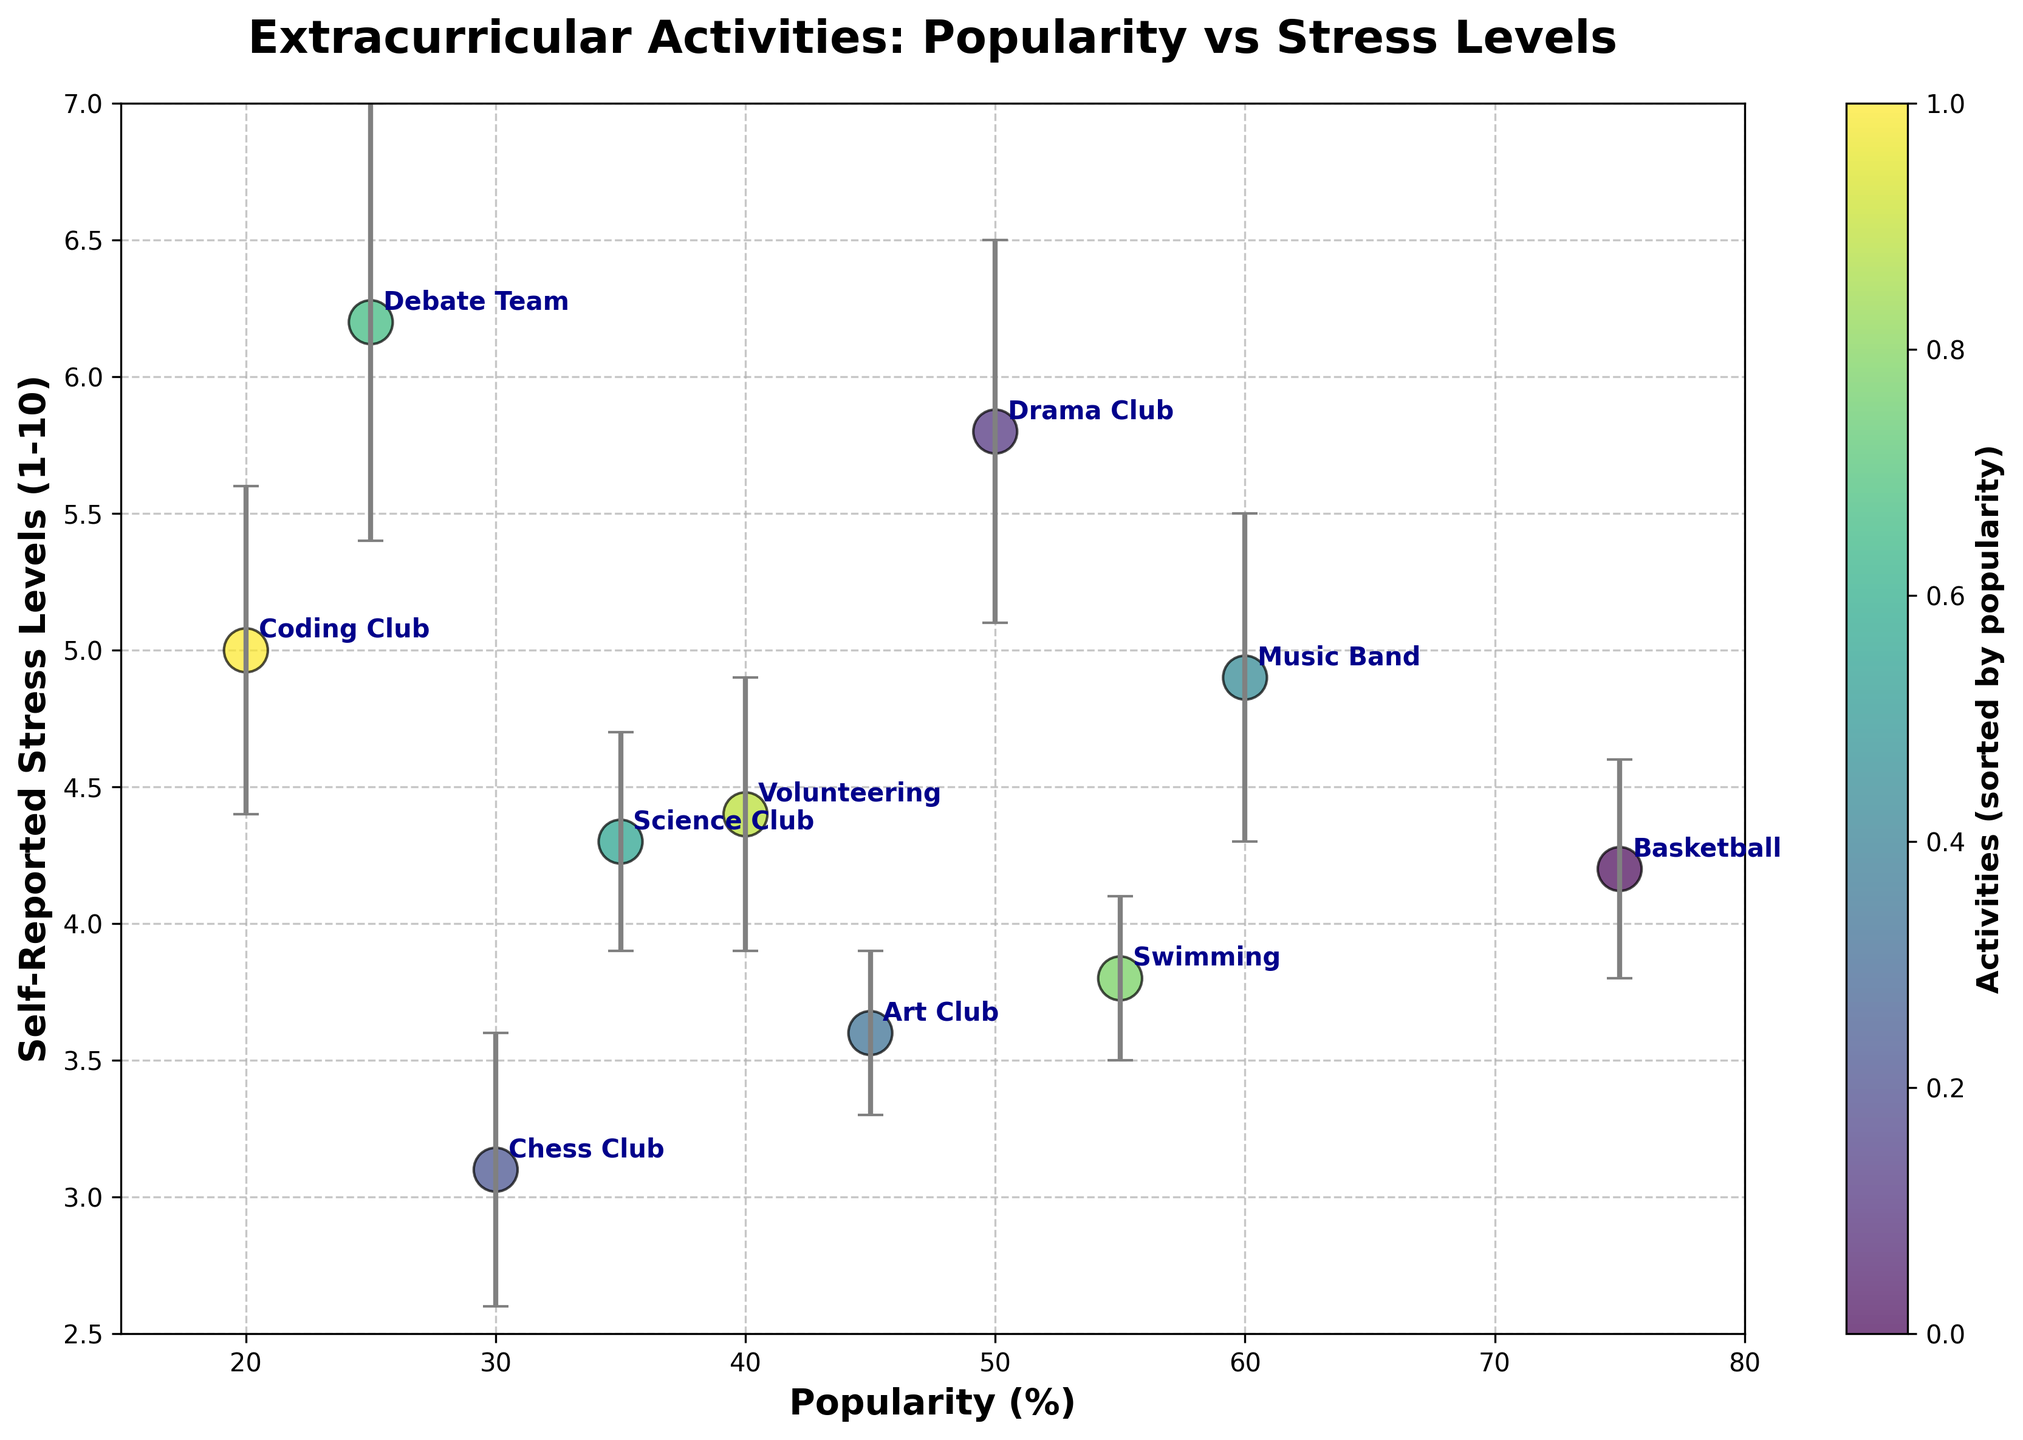Which activity has the highest popularity? To find the activity with the highest popularity, look at the x-axis and identify the point with the highest value. The activity plotted at that point is the most popular.
Answer: Basketball What's the range of self-reported stress levels for the Coding Club? First, find the point representing Coding Club, then look at the error bars extending from that point to estimate the stress variance. The stress level is 5.0, with a variance of 0.6, so the range is 5.0 ± 0.6.
Answer: 4.4 to 5.6 Which activity has the highest self-reported stress level? Identify the point on the scatter plot with the highest position on the y-axis. The activity annotated at that point has the highest self-reported stress level.
Answer: Debate Team Which activity has the lowest self-reported stress level? Identify the point on the scatter plot with the lowest position on the y-axis. The activity annotated at that point has the lowest self-reported stress level.
Answer: Chess Club Do activities with higher popularity generally have lower stress levels? Look at the overall trend of the scatter plot. The majority of higher popularity activities (right side of the plot) such as Basketball and Swimming have lower stress levels compared to less popular ones like Debate Team and Drama Club.
Answer: Yes, generally Comparing Drama Club and Music Band, which has higher variance in stress levels? Identify the points for Drama Club and Music Band, then compare the lengths of their error bars. Drama Club has a longer error bar, indicating higher variance.
Answer: Drama Club Which two activities have similar popularity but very different stress levels? Look for points along the x-axis (Popularity) that are close to each other but differ significantly in their y-axis values (Stress Levels). Music Band (60%) and Drama Club (50%) fit this criterion, with stress levels of 4.9 and 5.8, respectively.
Answer: Music Band and Drama Club Is there any activity near or exactly at 50% popularity? Check the scatter plot for points aligning close to the 50% mark on the x-axis. The activity at this point is Drama Club.
Answer: Drama Club What's the combined range of stress levels for Music Band and Coding Club? Music Band has a stress level of 4.9 ± 0.6, which ranges from 4.3 to 5.5. Coding Club's stress level is 5.0 ± 0.6, ranging from 4.4 to 5.6. Combining these, the overall range spans from 4.3 to 5.6.
Answer: 4.3 to 5.6 